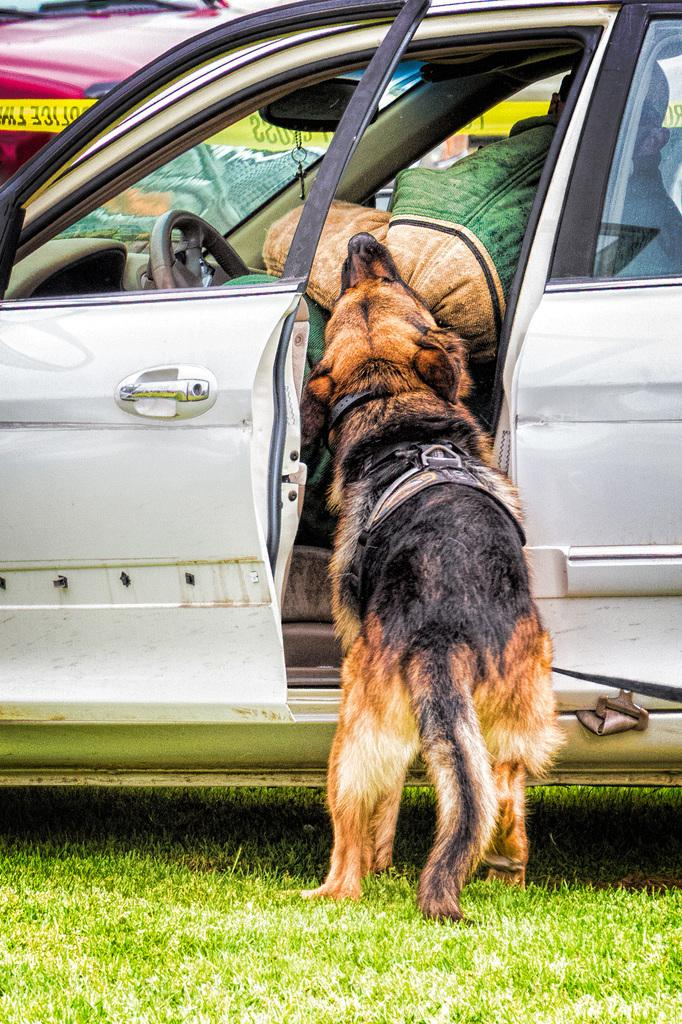What type of animal is in the image? There is a dog in the image. What else can be seen in the image besides the dog? There are cars in the image. Can you describe the person in the image? There is a person in a vehicle. What type of terrain is visible in the image? Grass is present in the image. What type of pie is the dog holding in the image? There is no pie present in the image, and the dog is not holding anything. 